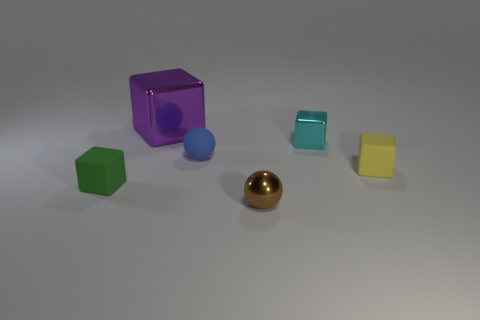Subtract all small green rubber cubes. How many cubes are left? 3 Subtract 1 cubes. How many cubes are left? 3 Subtract all purple cubes. How many cubes are left? 3 Add 2 tiny blue cubes. How many objects exist? 8 Subtract all cubes. How many objects are left? 2 Subtract all gray cubes. Subtract all green spheres. How many cubes are left? 4 Subtract all tiny blue rubber objects. Subtract all tiny rubber objects. How many objects are left? 2 Add 2 small cyan blocks. How many small cyan blocks are left? 3 Add 2 cyan metallic things. How many cyan metallic things exist? 3 Subtract 0 gray blocks. How many objects are left? 6 